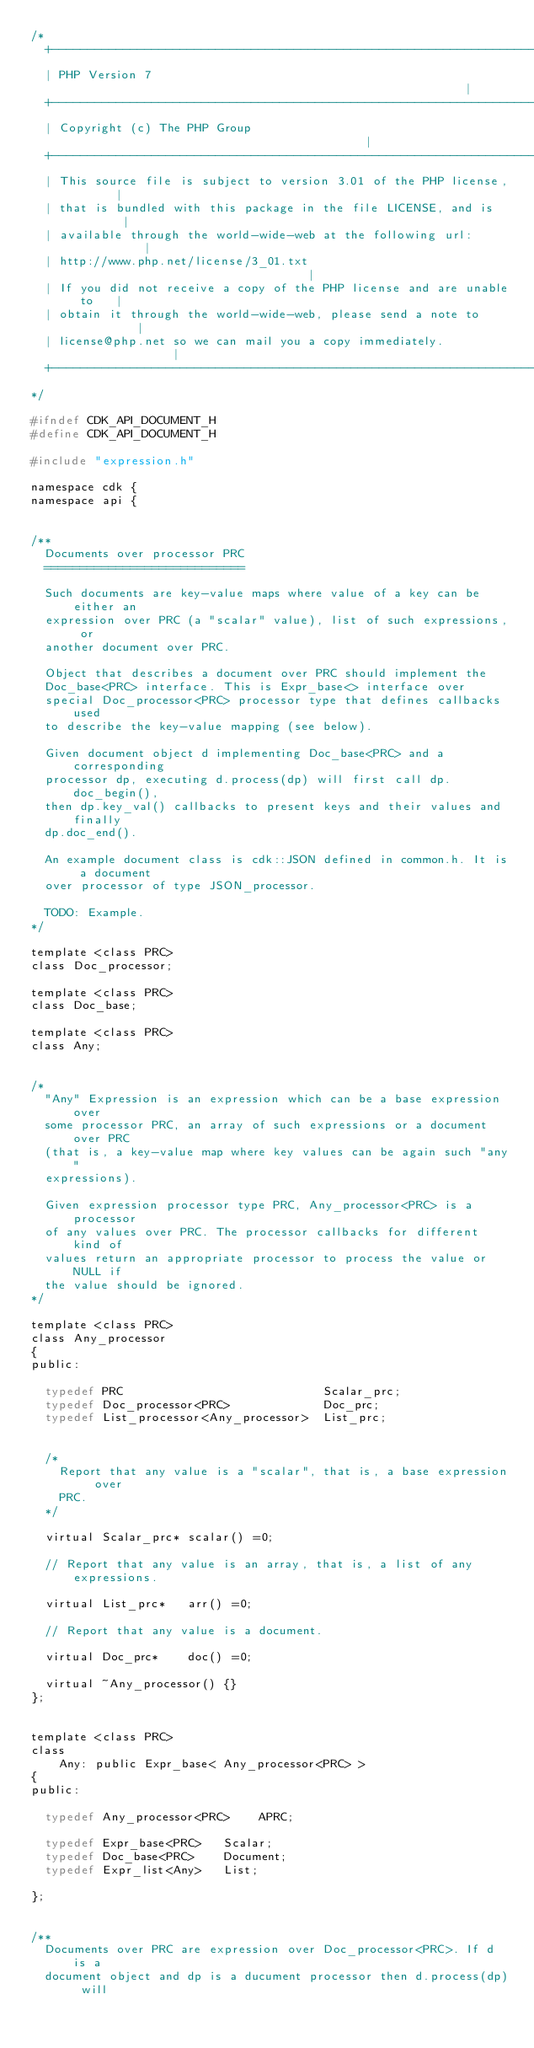<code> <loc_0><loc_0><loc_500><loc_500><_C_>/*
  +----------------------------------------------------------------------+
  | PHP Version 7                                                        |
  +----------------------------------------------------------------------+
  | Copyright (c) The PHP Group                                          |
  +----------------------------------------------------------------------+
  | This source file is subject to version 3.01 of the PHP license,      |
  | that is bundled with this package in the file LICENSE, and is        |
  | available through the world-wide-web at the following url:           |
  | http://www.php.net/license/3_01.txt                                  |
  | If you did not receive a copy of the PHP license and are unable to   |
  | obtain it through the world-wide-web, please send a note to          |
  | license@php.net so we can mail you a copy immediately.               |
  +----------------------------------------------------------------------+
*/

#ifndef CDK_API_DOCUMENT_H
#define CDK_API_DOCUMENT_H

#include "expression.h"

namespace cdk {
namespace api {


/**
  Documents over processor PRC
  ============================

  Such documents are key-value maps where value of a key can be either an
  expression over PRC (a "scalar" value), list of such expressions, or
  another document over PRC.

  Object that describes a document over PRC should implement the
  Doc_base<PRC> interface. This is Expr_base<> interface over
  special Doc_processor<PRC> processor type that defines callbacks used
  to describe the key-value mapping (see below).

  Given document object d implementing Doc_base<PRC> and a corresponding
  processor dp, executing d.process(dp) will first call dp.doc_begin(),
  then dp.key_val() callbacks to present keys and their values and finally
  dp.doc_end().

  An example document class is cdk::JSON defined in common.h. It is a document
  over processor of type JSON_processor.

  TODO: Example.
*/

template <class PRC>
class Doc_processor;

template <class PRC>
class Doc_base;

template <class PRC>
class Any;


/*
  "Any" Expression is an expression which can be a base expression over
  some processor PRC, an array of such expressions or a document over PRC
  (that is, a key-value map where key values can be again such "any"
  expressions).

  Given expression processor type PRC, Any_processor<PRC> is a processor
  of any values over PRC. The processor callbacks for different kind of
  values return an appropriate processor to process the value or NULL if
  the value should be ignored.
*/

template <class PRC>
class Any_processor
{
public:

  typedef PRC                            Scalar_prc;
  typedef Doc_processor<PRC>             Doc_prc;
  typedef List_processor<Any_processor>  List_prc;


  /*
    Report that any value is a "scalar", that is, a base expression over
    PRC.
  */

  virtual Scalar_prc* scalar() =0;

  // Report that any value is an array, that is, a list of any expressions.

  virtual List_prc*   arr() =0;

  // Report that any value is a document.

  virtual Doc_prc*    doc() =0;

  virtual ~Any_processor() {}
};


template <class PRC>
class
    Any: public Expr_base< Any_processor<PRC> >
{
public:

  typedef Any_processor<PRC>    APRC;

  typedef Expr_base<PRC>   Scalar;
  typedef Doc_base<PRC>    Document;
  typedef Expr_list<Any>   List;

};


/**
  Documents over PRC are expression over Doc_processor<PRC>. If d is a
  document object and dp is a ducument processor then d.process(dp) will</code> 